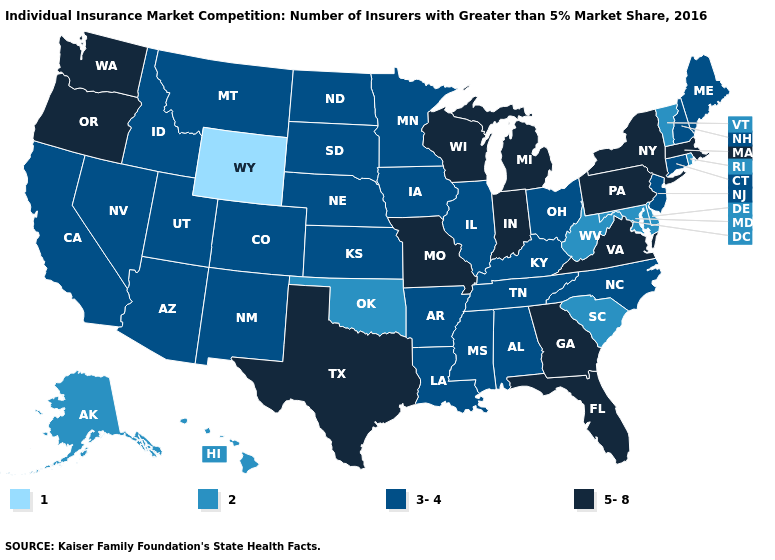Does Wyoming have the lowest value in the West?
Short answer required. Yes. What is the value of Indiana?
Be succinct. 5-8. Name the states that have a value in the range 5-8?
Write a very short answer. Florida, Georgia, Indiana, Massachusetts, Michigan, Missouri, New York, Oregon, Pennsylvania, Texas, Virginia, Washington, Wisconsin. What is the value of New Hampshire?
Concise answer only. 3-4. What is the value of Colorado?
Keep it brief. 3-4. Name the states that have a value in the range 3-4?
Quick response, please. Alabama, Arizona, Arkansas, California, Colorado, Connecticut, Idaho, Illinois, Iowa, Kansas, Kentucky, Louisiana, Maine, Minnesota, Mississippi, Montana, Nebraska, Nevada, New Hampshire, New Jersey, New Mexico, North Carolina, North Dakota, Ohio, South Dakota, Tennessee, Utah. What is the value of Louisiana?
Be succinct. 3-4. Name the states that have a value in the range 1?
Concise answer only. Wyoming. Name the states that have a value in the range 5-8?
Give a very brief answer. Florida, Georgia, Indiana, Massachusetts, Michigan, Missouri, New York, Oregon, Pennsylvania, Texas, Virginia, Washington, Wisconsin. What is the highest value in the USA?
Keep it brief. 5-8. Name the states that have a value in the range 5-8?
Answer briefly. Florida, Georgia, Indiana, Massachusetts, Michigan, Missouri, New York, Oregon, Pennsylvania, Texas, Virginia, Washington, Wisconsin. Among the states that border California , does Oregon have the highest value?
Quick response, please. Yes. Among the states that border Arkansas , which have the lowest value?
Concise answer only. Oklahoma. Among the states that border New Jersey , does Pennsylvania have the lowest value?
Quick response, please. No. Name the states that have a value in the range 1?
Answer briefly. Wyoming. 